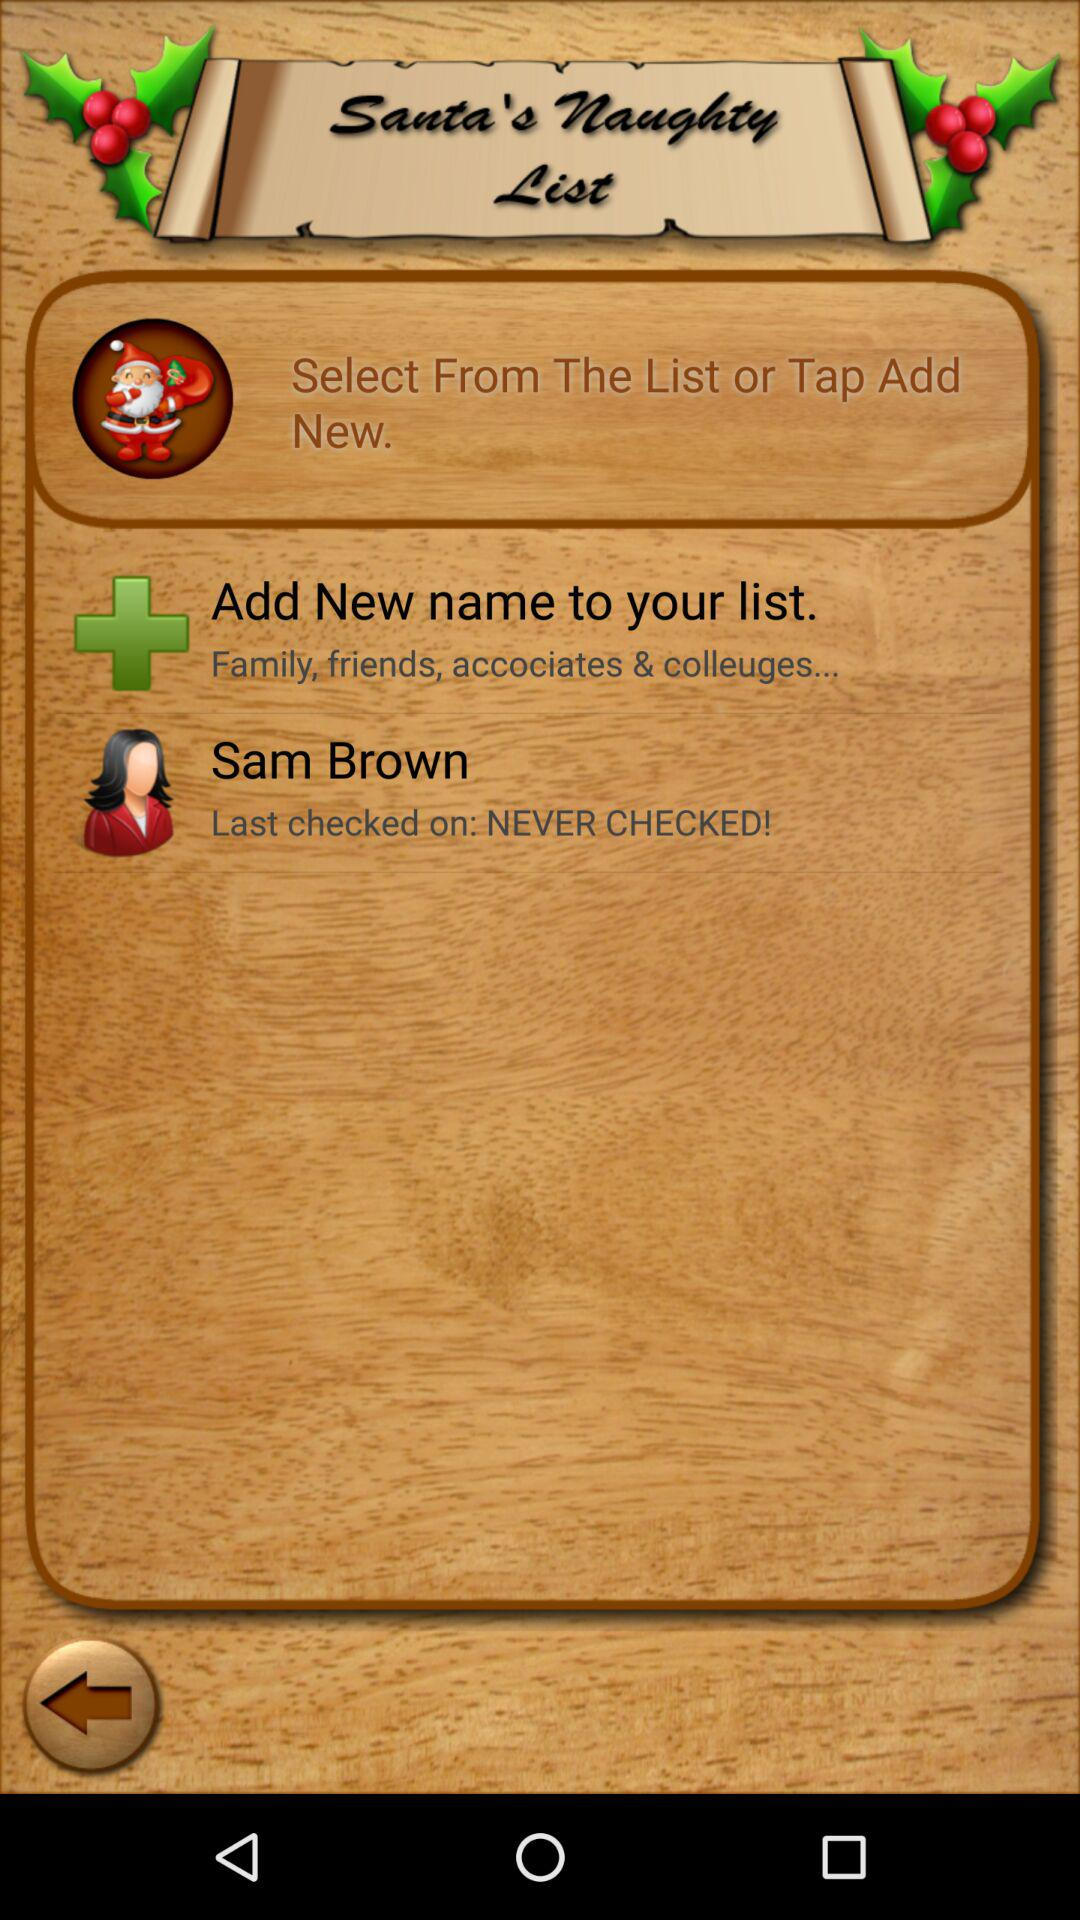What is the name of the user? The name of the user is Sam Brown. 